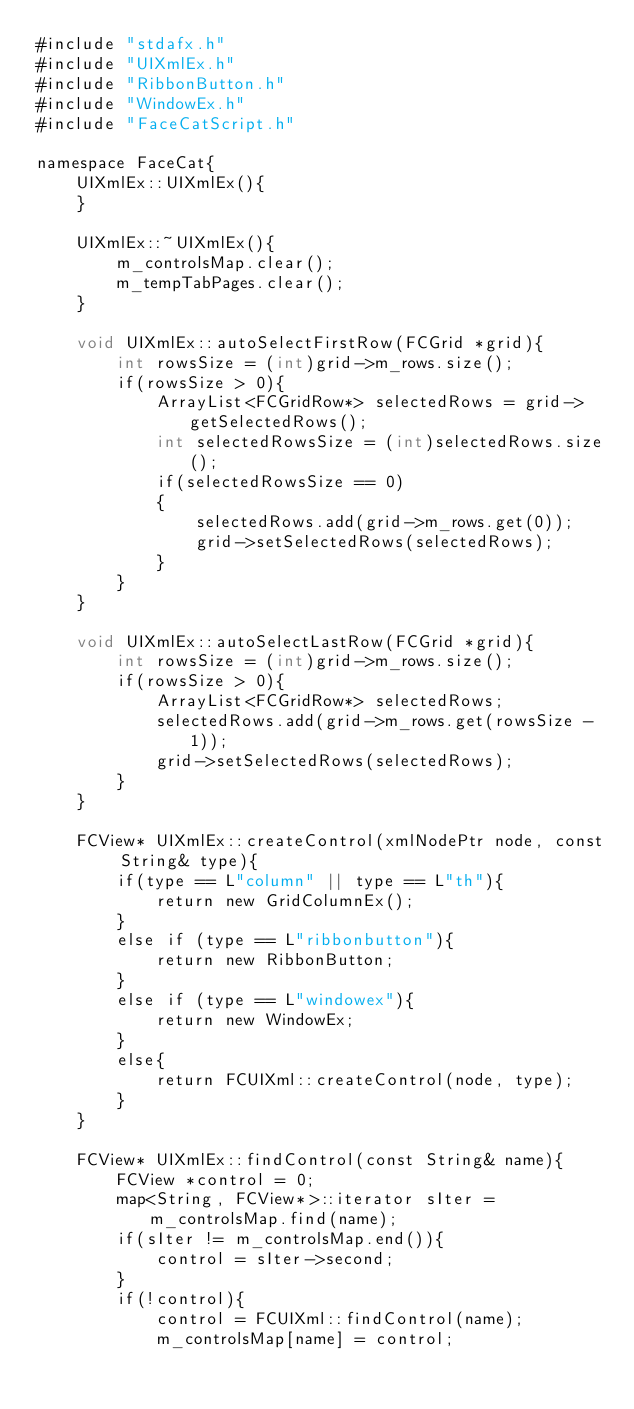<code> <loc_0><loc_0><loc_500><loc_500><_ObjectiveC_>#include "stdafx.h"
#include "UIXmlEx.h"
#include "RibbonButton.h"
#include "WindowEx.h"
#include "FaceCatScript.h"

namespace FaceCat{
    UIXmlEx::UIXmlEx(){
    }
    
    UIXmlEx::~UIXmlEx(){
        m_controlsMap.clear();
        m_tempTabPages.clear();
    }
    
    void UIXmlEx::autoSelectFirstRow(FCGrid *grid){
        int rowsSize = (int)grid->m_rows.size();
        if(rowsSize > 0){
            ArrayList<FCGridRow*> selectedRows = grid->getSelectedRows();
            int selectedRowsSize = (int)selectedRows.size();
            if(selectedRowsSize == 0)
            {
                selectedRows.add(grid->m_rows.get(0));
                grid->setSelectedRows(selectedRows);
            }
        }
    }
    
    void UIXmlEx::autoSelectLastRow(FCGrid *grid){
        int rowsSize = (int)grid->m_rows.size();
        if(rowsSize > 0){
            ArrayList<FCGridRow*> selectedRows;
            selectedRows.add(grid->m_rows.get(rowsSize - 1));
            grid->setSelectedRows(selectedRows);
        }
    }
    
    FCView* UIXmlEx::createControl(xmlNodePtr node, const String& type){
        if(type == L"column" || type == L"th"){
            return new GridColumnEx();
        }
        else if (type == L"ribbonbutton"){
            return new RibbonButton;
        }
        else if (type == L"windowex"){
            return new WindowEx;
        }
        else{
            return FCUIXml::createControl(node, type);
        }
    }
    
    FCView* UIXmlEx::findControl(const String& name){
        FCView *control = 0;
        map<String, FCView*>::iterator sIter = m_controlsMap.find(name);
        if(sIter != m_controlsMap.end()){
            control = sIter->second;
        }
        if(!control){
            control = FCUIXml::findControl(name);
            m_controlsMap[name] = control;</code> 